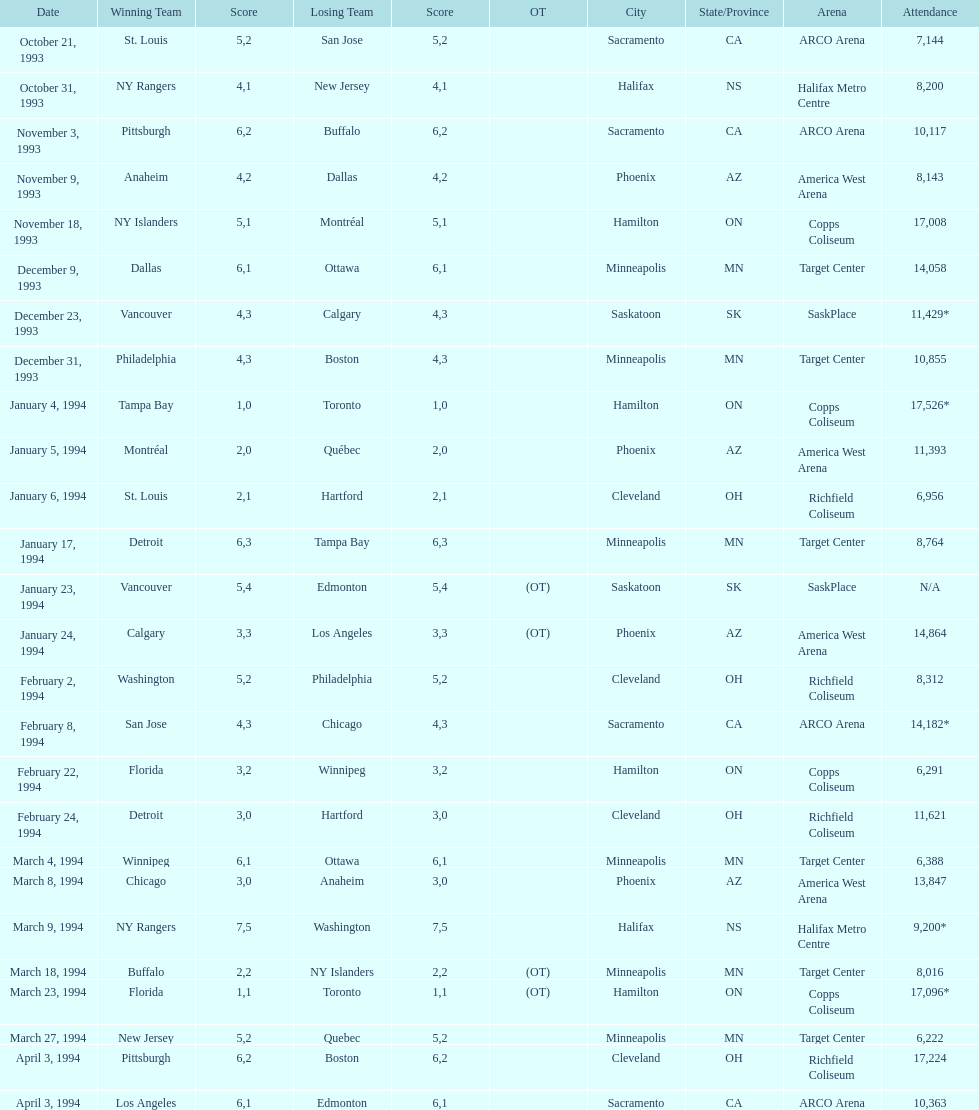Which function had a larger audience, january 24, 1994, or december 23, 1993? January 4, 1994. 